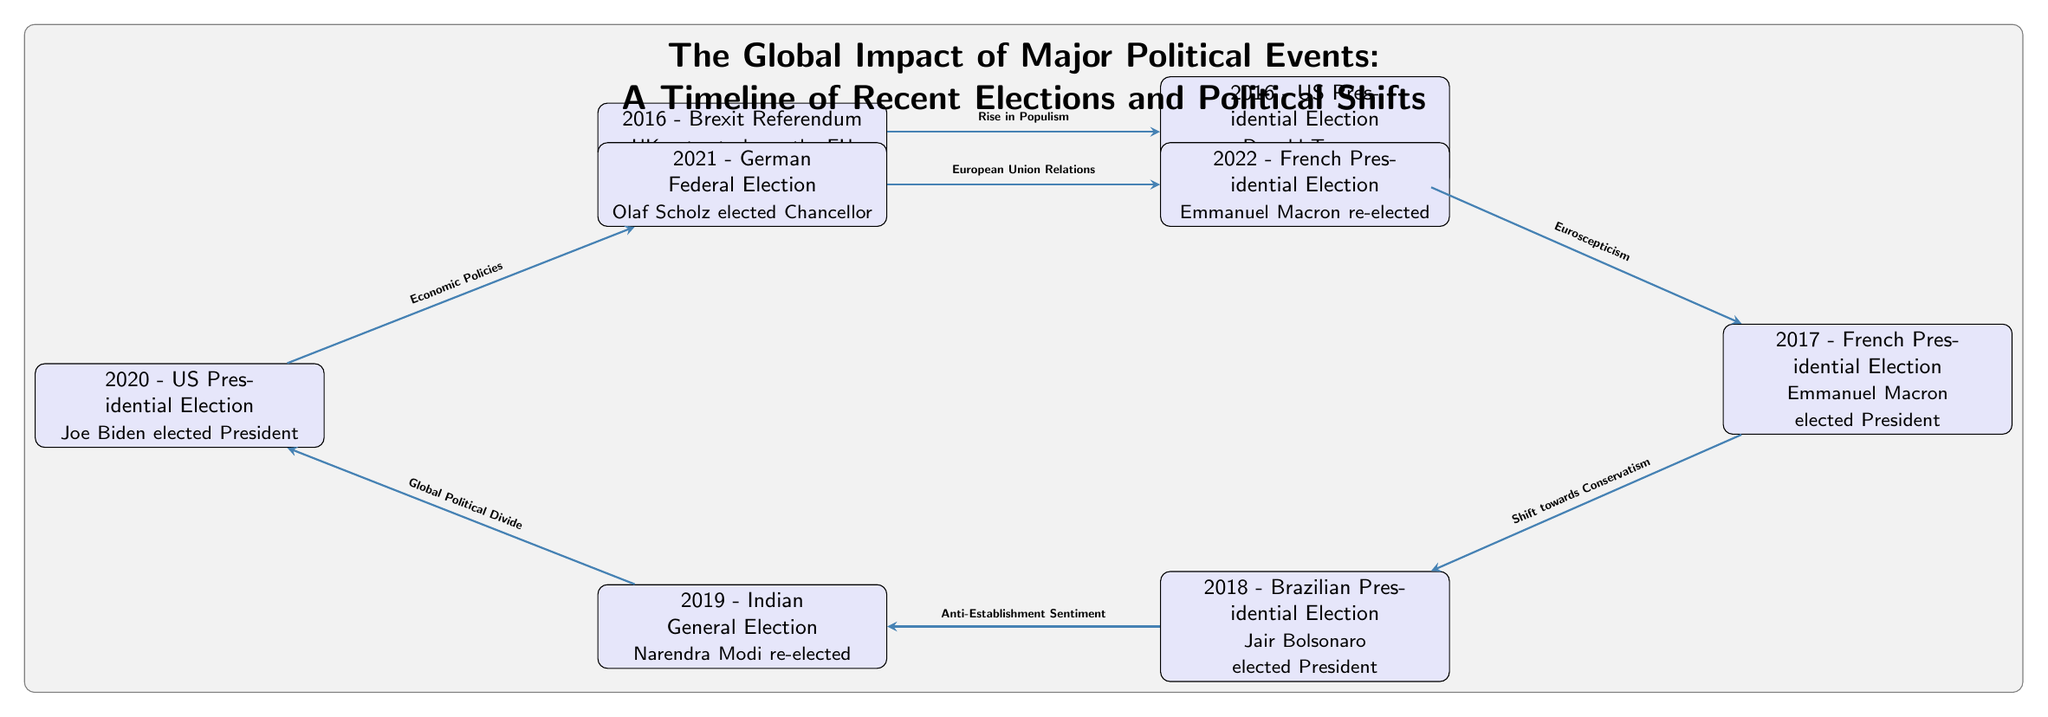What year did the Brexit Referendum occur? The diagram shows the Brexit Referendum as the first event, which is labeled with the year 2016.
Answer: 2016 How many political events are listed in the diagram? By counting the nodes in the diagram, there are a total of eight political events depicted.
Answer: 8 What was the outcome of the 2017 French Presidential Election? The diagram states that Emmanuel Macron was elected President during the 2017 French Presidential Election.
Answer: Emmanuel Macron elected President What connection is illustrated between the US Presidential Election of 2016 and the French Presidential Election of 2017? The diagram indicates that the connection between these two events is characterized by "Euroscepticism."
Answer: Euroscepticism Which political event is represented immediately after Joe Biden's election in 2020? Following Joe Biden's election in 2020, the diagram represents the 2021 German Federal Election as the next event.
Answer: 2021 - German Federal Election What type of sentiment is linked to Jair Bolsonaro's election in 2018? The diagram shows that Jair Bolsonaro's election is associated with "Anti-Establishment Sentiment."
Answer: Anti-Establishment Sentiment What is the relationship between the 2019 Indian General Election and the 2020 US Presidential Election? The relationship indicated in the diagram between these two events is a "Global Political Divide."
Answer: Global Political Divide How does the diagram categorize the political shift from Emmanuel Macron's election in 2017 to Jair Bolsonaro's election in 2018? The shift between these elections is qualified by "Shift towards Conservatism," as indicated in the diagram.
Answer: Shift towards Conservatism What is the final political event recorded in the timeline? The diagram ends with the 2022 French Presidential Election, where Emmanuel Macron was re-elected.
Answer: 2022 - French Presidential Election 